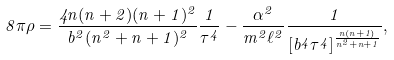<formula> <loc_0><loc_0><loc_500><loc_500>8 \pi \rho = \frac { 4 n ( n + 2 ) ( n + 1 ) ^ { 2 } } { b ^ { 2 } ( n ^ { 2 } + n + 1 ) ^ { 2 } } \frac { 1 } { \tau ^ { 4 } } - \frac { \alpha ^ { 2 } } { m ^ { 2 } \ell ^ { 2 } } \frac { 1 } { [ b ^ { 4 } \tau ^ { 4 } ] ^ { \frac { n ( n + 1 ) } { n ^ { 2 } + n + 1 } } } ,</formula> 